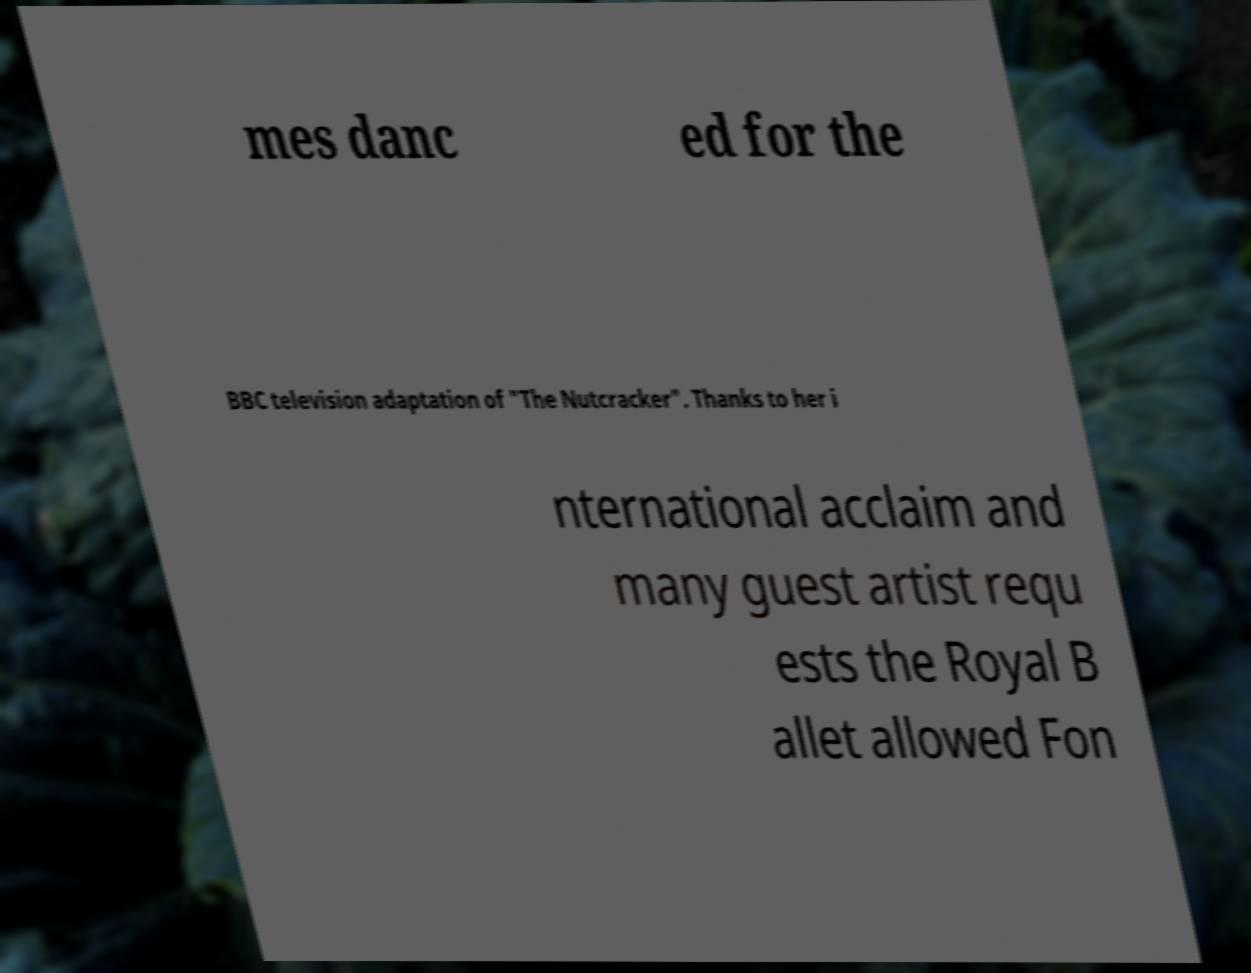For documentation purposes, I need the text within this image transcribed. Could you provide that? mes danc ed for the BBC television adaptation of "The Nutcracker". Thanks to her i nternational acclaim and many guest artist requ ests the Royal B allet allowed Fon 